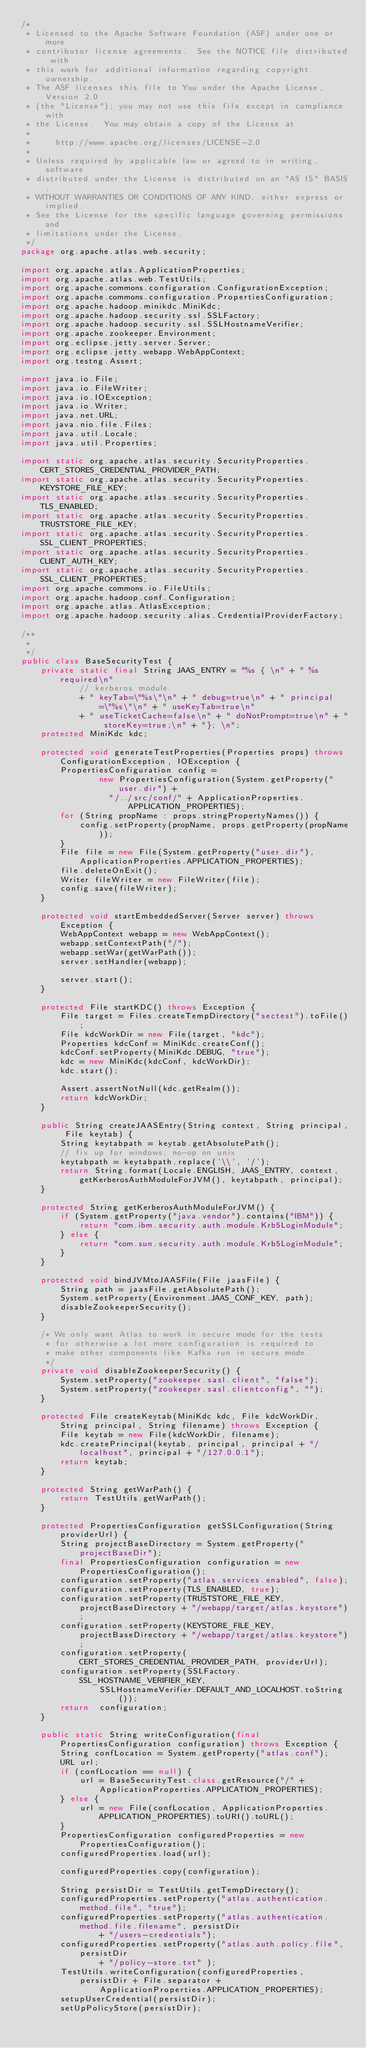<code> <loc_0><loc_0><loc_500><loc_500><_Java_>/*
 * Licensed to the Apache Software Foundation (ASF) under one or more
 * contributor license agreements.  See the NOTICE file distributed with
 * this work for additional information regarding copyright ownership.
 * The ASF licenses this file to You under the Apache License, Version 2.0
 * (the "License"); you may not use this file except in compliance with
 * the License.  You may obtain a copy of the License at
 *
 *     http://www.apache.org/licenses/LICENSE-2.0
 *
 * Unless required by applicable law or agreed to in writing, software
 * distributed under the License is distributed on an "AS IS" BASIS,
 * WITHOUT WARRANTIES OR CONDITIONS OF ANY KIND, either express or implied.
 * See the License for the specific language governing permissions and
 * limitations under the License.
 */
package org.apache.atlas.web.security;

import org.apache.atlas.ApplicationProperties;
import org.apache.atlas.web.TestUtils;
import org.apache.commons.configuration.ConfigurationException;
import org.apache.commons.configuration.PropertiesConfiguration;
import org.apache.hadoop.minikdc.MiniKdc;
import org.apache.hadoop.security.ssl.SSLFactory;
import org.apache.hadoop.security.ssl.SSLHostnameVerifier;
import org.apache.zookeeper.Environment;
import org.eclipse.jetty.server.Server;
import org.eclipse.jetty.webapp.WebAppContext;
import org.testng.Assert;

import java.io.File;
import java.io.FileWriter;
import java.io.IOException;
import java.io.Writer;
import java.net.URL;
import java.nio.file.Files;
import java.util.Locale;
import java.util.Properties;

import static org.apache.atlas.security.SecurityProperties.CERT_STORES_CREDENTIAL_PROVIDER_PATH;
import static org.apache.atlas.security.SecurityProperties.KEYSTORE_FILE_KEY;
import static org.apache.atlas.security.SecurityProperties.TLS_ENABLED;
import static org.apache.atlas.security.SecurityProperties.TRUSTSTORE_FILE_KEY;
import static org.apache.atlas.security.SecurityProperties.SSL_CLIENT_PROPERTIES;
import static org.apache.atlas.security.SecurityProperties.CLIENT_AUTH_KEY;
import static org.apache.atlas.security.SecurityProperties.SSL_CLIENT_PROPERTIES;
import org.apache.commons.io.FileUtils;
import org.apache.hadoop.conf.Configuration;
import org.apache.atlas.AtlasException;
import org.apache.hadoop.security.alias.CredentialProviderFactory;

/**
 *
 */
public class BaseSecurityTest {
    private static final String JAAS_ENTRY = "%s { \n" + " %s required\n"
            // kerberos module
            + " keyTab=\"%s\"\n" + " debug=true\n" + " principal=\"%s\"\n" + " useKeyTab=true\n"
            + " useTicketCache=false\n" + " doNotPrompt=true\n" + " storeKey=true;\n" + "}; \n";
    protected MiniKdc kdc;

    protected void generateTestProperties(Properties props) throws ConfigurationException, IOException {
        PropertiesConfiguration config =
                new PropertiesConfiguration(System.getProperty("user.dir") +
                  "/../src/conf/" + ApplicationProperties.APPLICATION_PROPERTIES);
        for (String propName : props.stringPropertyNames()) {
            config.setProperty(propName, props.getProperty(propName));
        }
        File file = new File(System.getProperty("user.dir"), ApplicationProperties.APPLICATION_PROPERTIES);
        file.deleteOnExit();
        Writer fileWriter = new FileWriter(file);
        config.save(fileWriter);
    }

    protected void startEmbeddedServer(Server server) throws Exception {
        WebAppContext webapp = new WebAppContext();
        webapp.setContextPath("/");
        webapp.setWar(getWarPath());
        server.setHandler(webapp);

        server.start();
    }

    protected File startKDC() throws Exception {
        File target = Files.createTempDirectory("sectest").toFile();
        File kdcWorkDir = new File(target, "kdc");
        Properties kdcConf = MiniKdc.createConf();
        kdcConf.setProperty(MiniKdc.DEBUG, "true");
        kdc = new MiniKdc(kdcConf, kdcWorkDir);
        kdc.start();

        Assert.assertNotNull(kdc.getRealm());
        return kdcWorkDir;
    }

    public String createJAASEntry(String context, String principal, File keytab) {
        String keytabpath = keytab.getAbsolutePath();
        // fix up for windows; no-op on unix
        keytabpath = keytabpath.replace('\\', '/');
        return String.format(Locale.ENGLISH, JAAS_ENTRY, context, getKerberosAuthModuleForJVM(), keytabpath, principal);
    }

    protected String getKerberosAuthModuleForJVM() {
        if (System.getProperty("java.vendor").contains("IBM")) {
            return "com.ibm.security.auth.module.Krb5LoginModule";
        } else {
            return "com.sun.security.auth.module.Krb5LoginModule";
        }
    }

    protected void bindJVMtoJAASFile(File jaasFile) {
        String path = jaasFile.getAbsolutePath();
        System.setProperty(Environment.JAAS_CONF_KEY, path);
        disableZookeeperSecurity();
    }

    /* We only want Atlas to work in secure mode for the tests
     * for otherwise a lot more configuration is required to
     * make other components like Kafka run in secure mode.
     */
    private void disableZookeeperSecurity() {
        System.setProperty("zookeeper.sasl.client", "false");
        System.setProperty("zookeeper.sasl.clientconfig", "");
    }

    protected File createKeytab(MiniKdc kdc, File kdcWorkDir, String principal, String filename) throws Exception {
        File keytab = new File(kdcWorkDir, filename);
        kdc.createPrincipal(keytab, principal, principal + "/localhost", principal + "/127.0.0.1");
        return keytab;
    }

    protected String getWarPath() {
        return TestUtils.getWarPath();
    }

    protected PropertiesConfiguration getSSLConfiguration(String providerUrl) {
        String projectBaseDirectory = System.getProperty("projectBaseDir");
        final PropertiesConfiguration configuration = new PropertiesConfiguration();
        configuration.setProperty("atlas.services.enabled", false);
        configuration.setProperty(TLS_ENABLED, true);
        configuration.setProperty(TRUSTSTORE_FILE_KEY, projectBaseDirectory + "/webapp/target/atlas.keystore");
        configuration.setProperty(KEYSTORE_FILE_KEY, projectBaseDirectory + "/webapp/target/atlas.keystore");
        configuration.setProperty(CERT_STORES_CREDENTIAL_PROVIDER_PATH, providerUrl);
        configuration.setProperty(SSLFactory.SSL_HOSTNAME_VERIFIER_KEY,
                SSLHostnameVerifier.DEFAULT_AND_LOCALHOST.toString());
        return  configuration;
    }

    public static String writeConfiguration(final PropertiesConfiguration configuration) throws Exception {
        String confLocation = System.getProperty("atlas.conf");
        URL url;
        if (confLocation == null) {
            url = BaseSecurityTest.class.getResource("/" + ApplicationProperties.APPLICATION_PROPERTIES);
        } else {
            url = new File(confLocation, ApplicationProperties.APPLICATION_PROPERTIES).toURI().toURL();
        }
        PropertiesConfiguration configuredProperties = new PropertiesConfiguration();
        configuredProperties.load(url);

        configuredProperties.copy(configuration);

        String persistDir = TestUtils.getTempDirectory();
        configuredProperties.setProperty("atlas.authentication.method.file", "true");
        configuredProperties.setProperty("atlas.authentication.method.file.filename", persistDir
                + "/users-credentials");
        configuredProperties.setProperty("atlas.auth.policy.file",persistDir
                + "/policy-store.txt" );
        TestUtils.writeConfiguration(configuredProperties, persistDir + File.separator +
                ApplicationProperties.APPLICATION_PROPERTIES);
        setupUserCredential(persistDir);
        setUpPolicyStore(persistDir);</code> 